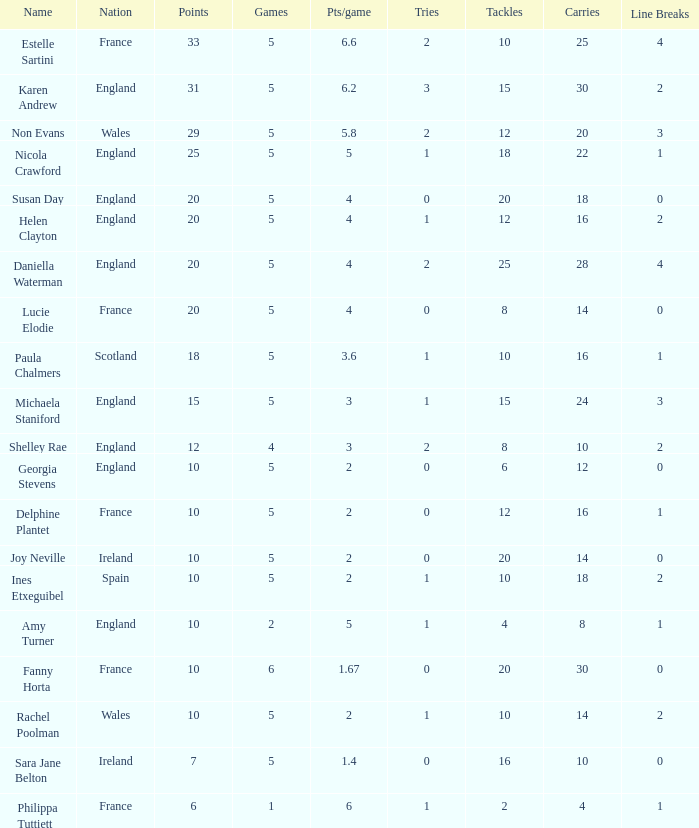Can you tell me the lowest Pts/game that has the Games larger than 6? None. 